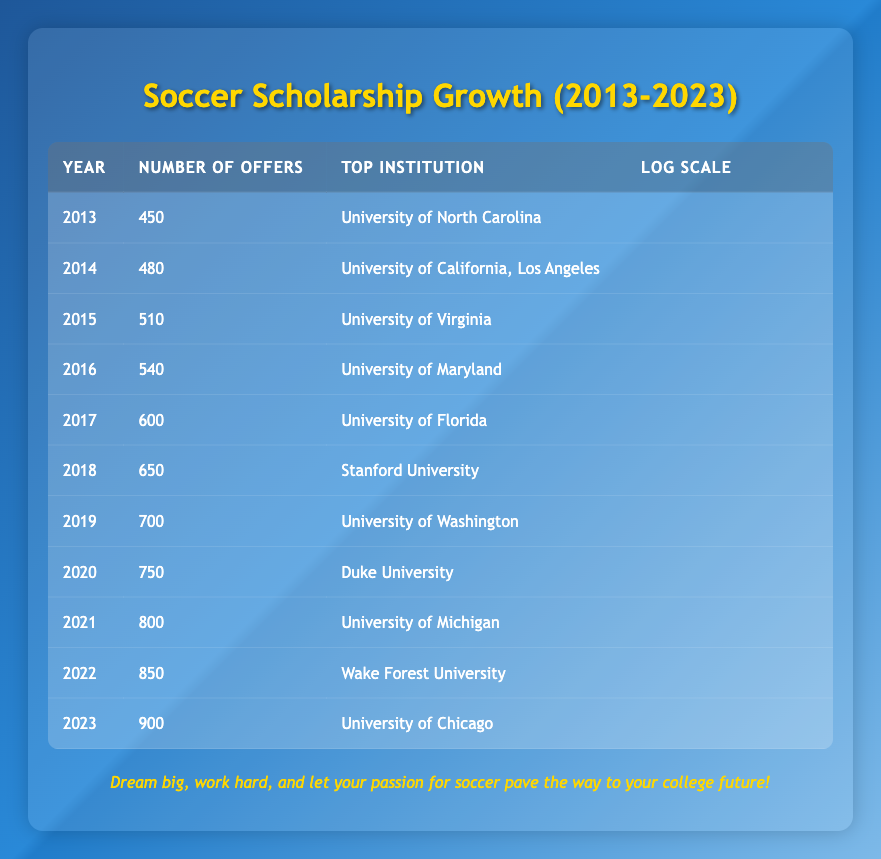What was the total number of scholarship offers in 2022? The scholarship offers for 2022 are 850 according to the table.
Answer: 850 Which year had the highest number of scholarship offers? The highest number of scholarship offers, 900, occurred in 2023 as shown in the table.
Answer: 2023 What is the percentage increase in scholarship offers from 2013 to 2023? The increase from 450 in 2013 to 900 in 2023 is 900 - 450 = 450. The percentage increase is (450 / 450) * 100 = 100%.
Answer: 100% Is it true that the University of Michigan was the top institution in 2021? Yes, according to the table, the University of Michigan is listed as the top institution for 2021.
Answer: Yes How many scholarship offers were there in 2018 compared to 2016, and what was the difference? In 2018, there were 650 offers, and in 2016, there were 540 offers. The difference is 650 - 540 = 110.
Answer: 110 What was the average number of scholarship offers between 2015 and 2021? Summing the offers from 2015 to 2021 gives (510 + 540 + 600 + 650 + 750 + 800) = 3850. There are 7 years, so the average is 3850 / 7 = approximately 550.
Answer: 550 Did the number of scholarship offers increase every year from 2013 to 2023? Yes, reviewing the table indicates that the number of offers increased each year without exception between 2013 and 2023.
Answer: Yes Which institution offered the most scholarships in 2019? The table shows that the University of Washington offered the most scholarships in 2019, with 700 offers.
Answer: University of Washington What is the difference in scholarship offers between the years 2017 and 2019? The number of offers in 2017 was 600 and in 2019 was 700. The difference is 700 - 600 = 100.
Answer: 100 